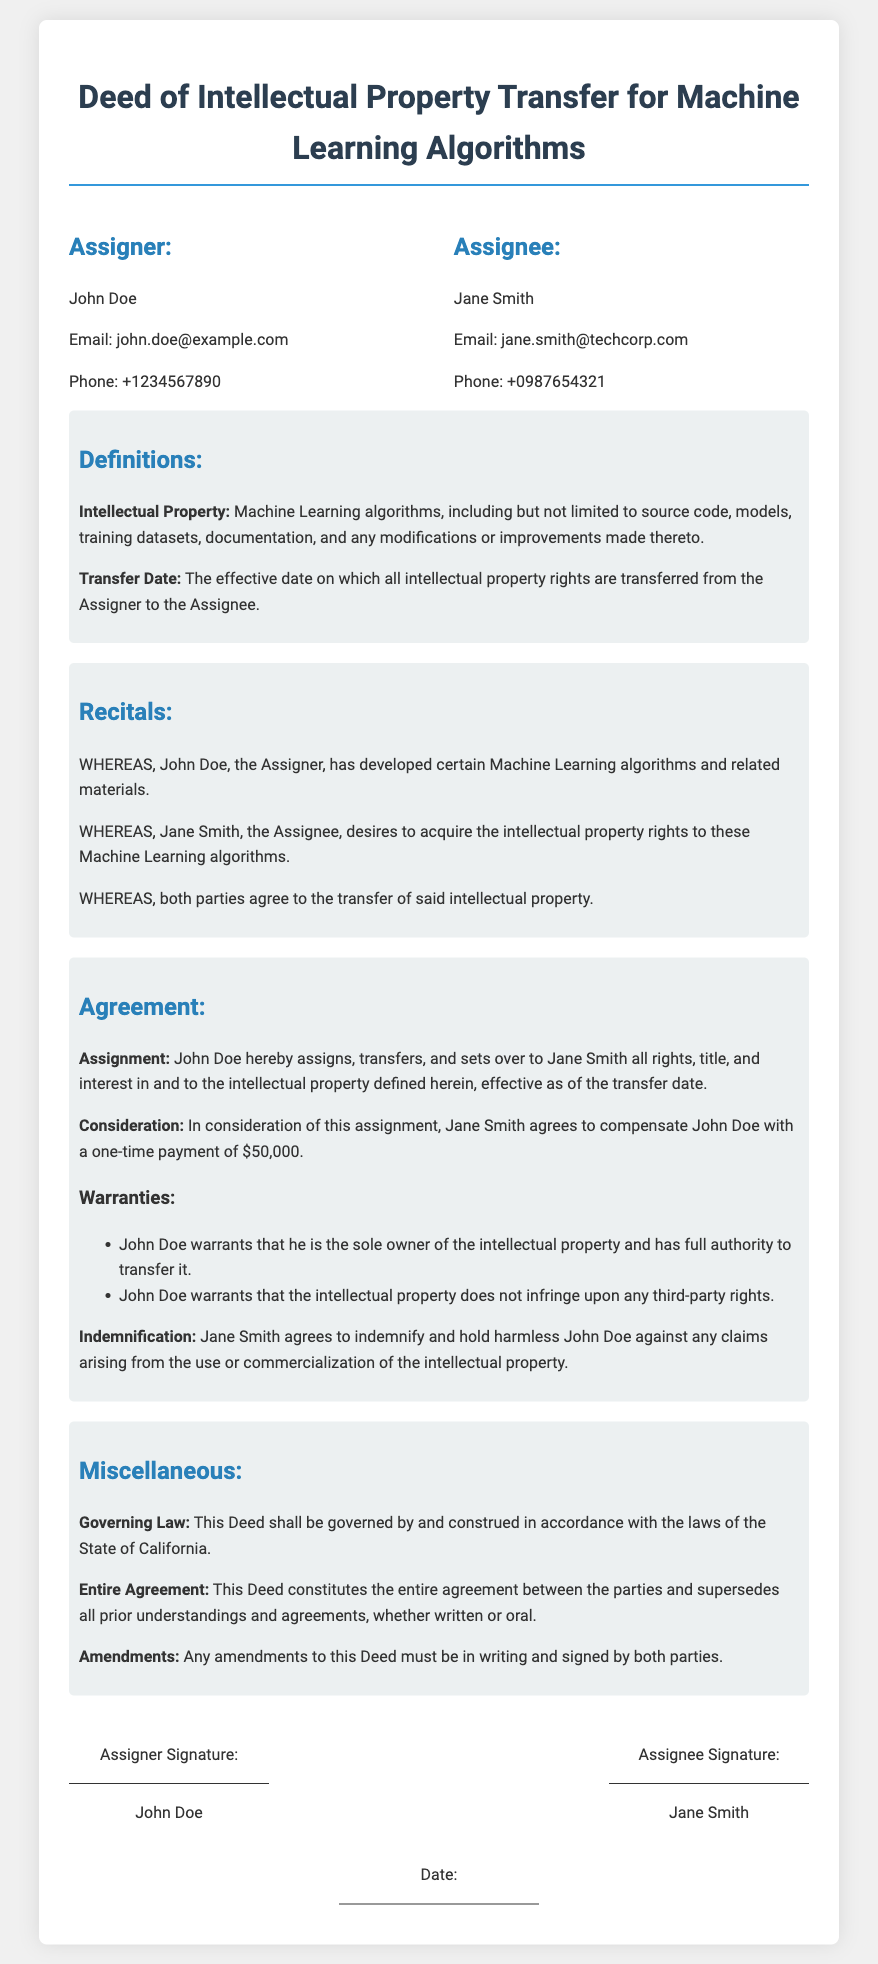What is the Assigner's name? The Assigner's name is specified in the parties section of the document.
Answer: John Doe What is the Assignee's email? The Assignee's email is listed under the Assignee's contact information in the parties section.
Answer: jane.smith@techcorp.com What is the one-time payment amount for the transfer? The payment amount is mentioned in the consideration section of the agreement.
Answer: $50,000 What date is the deed governed by? The governing law for the deed is stated in the miscellaneous section.
Answer: California What does John Doe warrant regarding ownership? This refers to the warranties described in the agreement, specifically about ownership.
Answer: Sole owner Who agrees to indemnify John Doe? This is stated in the indemnification clause of the agreement.
Answer: Jane Smith What type of document is this? This is identified in the title of the document and is unique to its contents.
Answer: Deed of Intellectual Property Transfer What must be done for amendments to be valid? The requirements for amendments are specified in the miscellaneous section of the document.
Answer: Must be in writing What is included in the definition of Intellectual Property? The definition section details what is included as intellectual property.
Answer: Machine Learning algorithms, including but not limited to source code, models, training datasets, documentation, and any modifications or improvements made thereto 